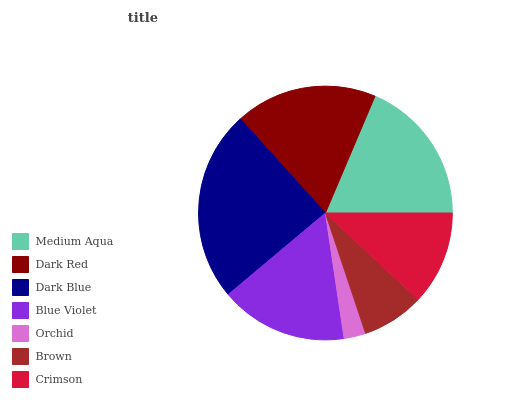Is Orchid the minimum?
Answer yes or no. Yes. Is Dark Blue the maximum?
Answer yes or no. Yes. Is Dark Red the minimum?
Answer yes or no. No. Is Dark Red the maximum?
Answer yes or no. No. Is Medium Aqua greater than Dark Red?
Answer yes or no. Yes. Is Dark Red less than Medium Aqua?
Answer yes or no. Yes. Is Dark Red greater than Medium Aqua?
Answer yes or no. No. Is Medium Aqua less than Dark Red?
Answer yes or no. No. Is Blue Violet the high median?
Answer yes or no. Yes. Is Blue Violet the low median?
Answer yes or no. Yes. Is Medium Aqua the high median?
Answer yes or no. No. Is Brown the low median?
Answer yes or no. No. 